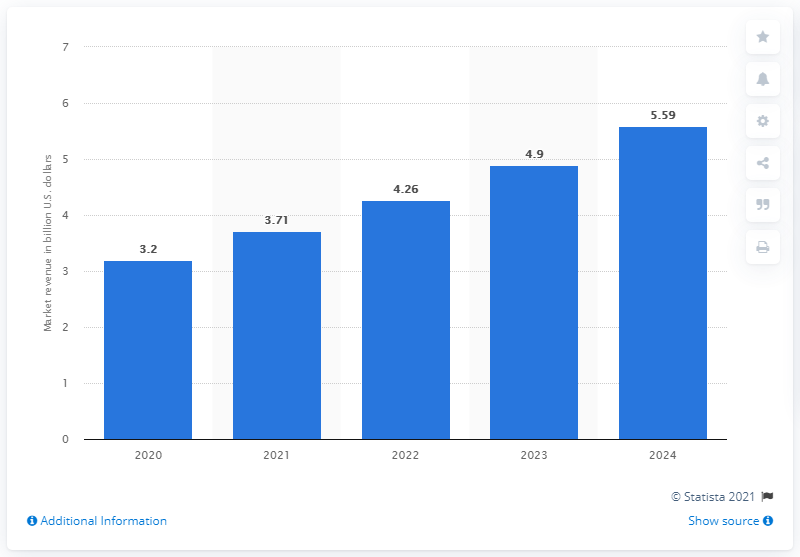Highlight a few significant elements in this photo. The estimated value of the secure email gateway market in dollars in 2024 is expected to be approximately 5.59... 